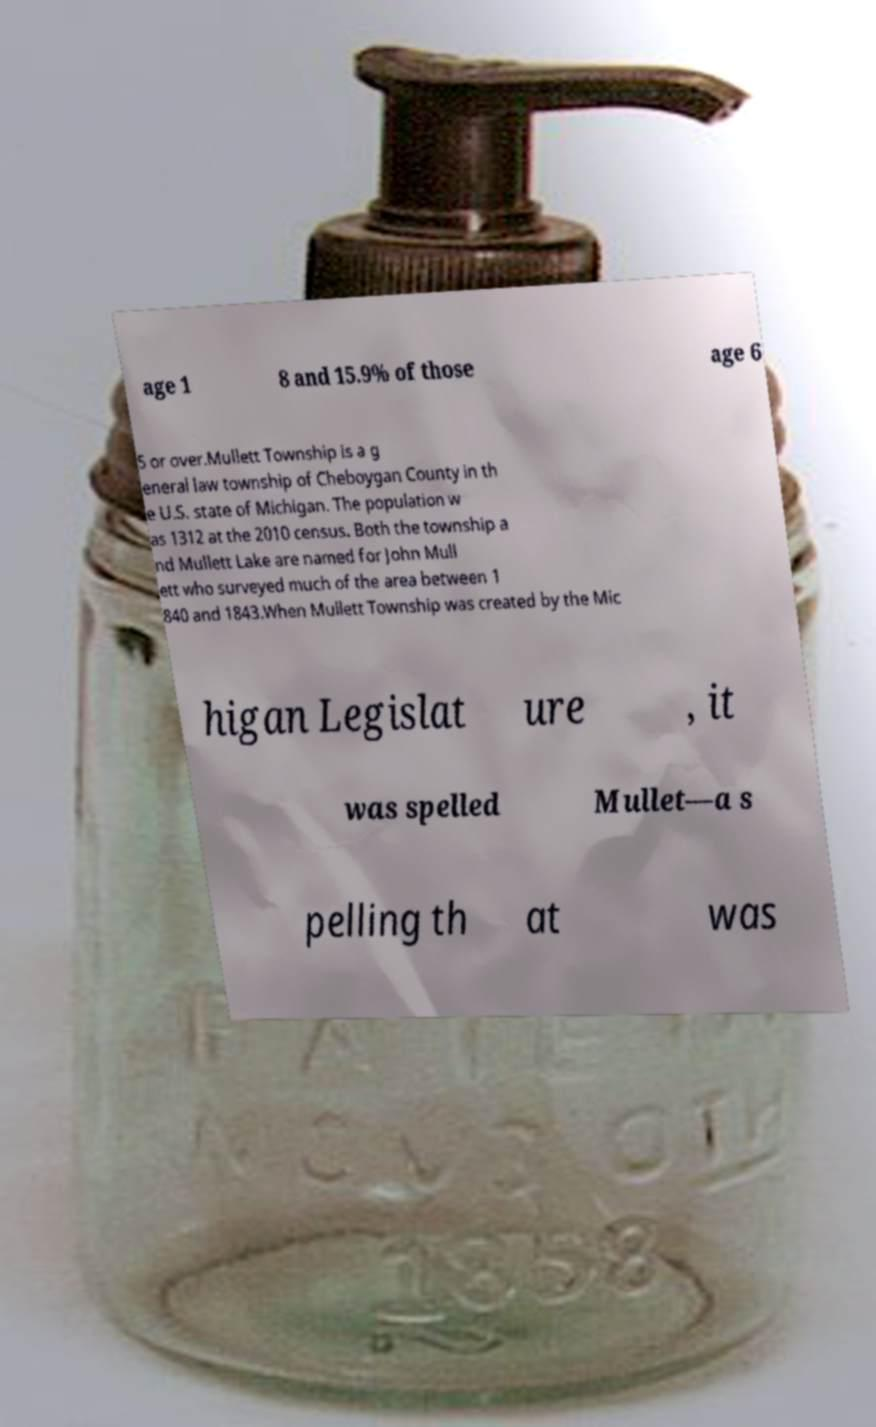Could you extract and type out the text from this image? age 1 8 and 15.9% of those age 6 5 or over.Mullett Township is a g eneral law township of Cheboygan County in th e U.S. state of Michigan. The population w as 1312 at the 2010 census. Both the township a nd Mullett Lake are named for John Mull ett who surveyed much of the area between 1 840 and 1843.When Mullett Township was created by the Mic higan Legislat ure , it was spelled Mullet—a s pelling th at was 